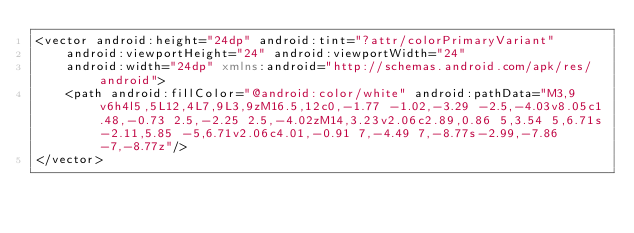Convert code to text. <code><loc_0><loc_0><loc_500><loc_500><_XML_><vector android:height="24dp" android:tint="?attr/colorPrimaryVariant"
    android:viewportHeight="24" android:viewportWidth="24"
    android:width="24dp" xmlns:android="http://schemas.android.com/apk/res/android">
    <path android:fillColor="@android:color/white" android:pathData="M3,9v6h4l5,5L12,4L7,9L3,9zM16.5,12c0,-1.77 -1.02,-3.29 -2.5,-4.03v8.05c1.48,-0.73 2.5,-2.25 2.5,-4.02zM14,3.23v2.06c2.89,0.86 5,3.54 5,6.71s-2.11,5.85 -5,6.71v2.06c4.01,-0.91 7,-4.49 7,-8.77s-2.99,-7.86 -7,-8.77z"/>
</vector>
</code> 